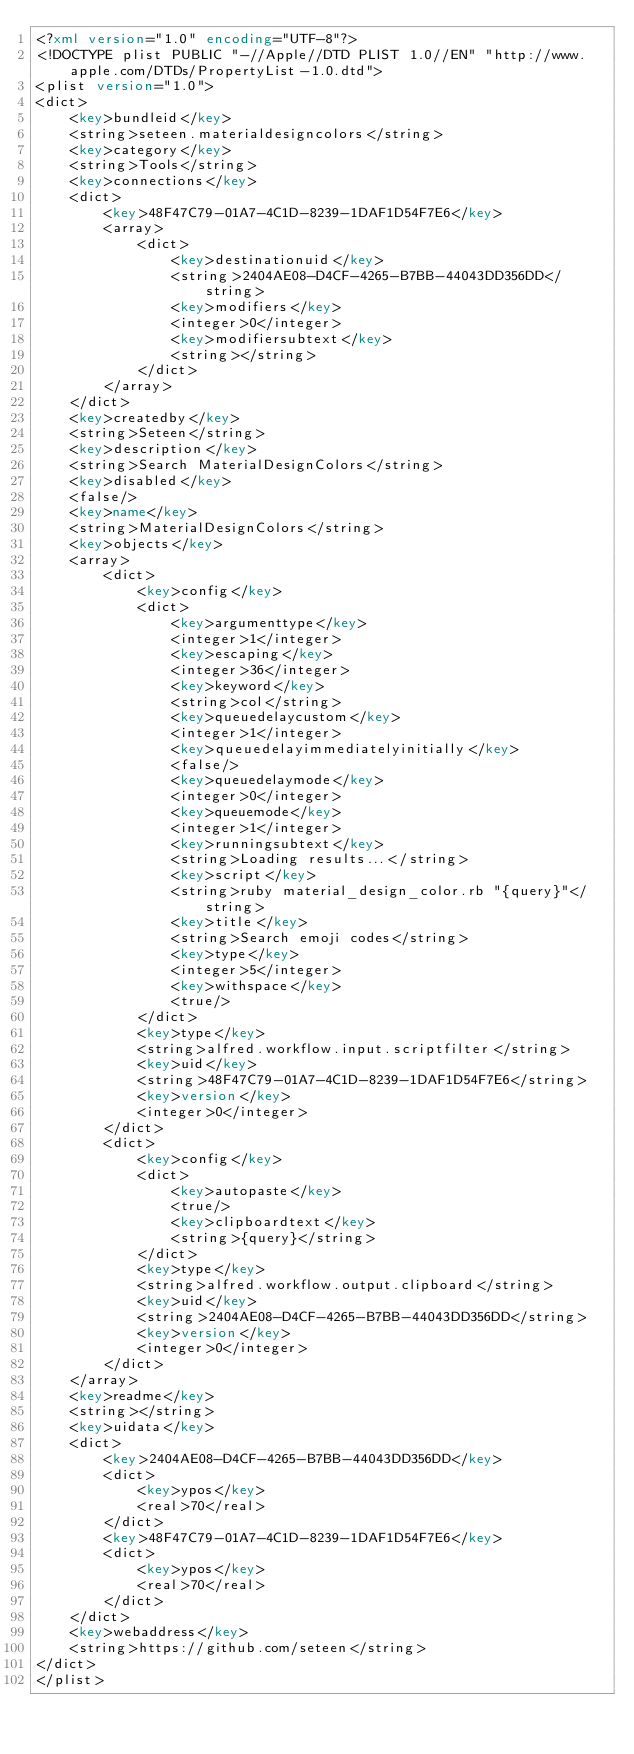Convert code to text. <code><loc_0><loc_0><loc_500><loc_500><_XML_><?xml version="1.0" encoding="UTF-8"?>
<!DOCTYPE plist PUBLIC "-//Apple//DTD PLIST 1.0//EN" "http://www.apple.com/DTDs/PropertyList-1.0.dtd">
<plist version="1.0">
<dict>
	<key>bundleid</key>
	<string>seteen.materialdesigncolors</string>
	<key>category</key>
	<string>Tools</string>
	<key>connections</key>
	<dict>
		<key>48F47C79-01A7-4C1D-8239-1DAF1D54F7E6</key>
		<array>
			<dict>
				<key>destinationuid</key>
				<string>2404AE08-D4CF-4265-B7BB-44043DD356DD</string>
				<key>modifiers</key>
				<integer>0</integer>
				<key>modifiersubtext</key>
				<string></string>
			</dict>
		</array>
	</dict>
	<key>createdby</key>
	<string>Seteen</string>
	<key>description</key>
	<string>Search MaterialDesignColors</string>
	<key>disabled</key>
	<false/>
	<key>name</key>
	<string>MaterialDesignColors</string>
	<key>objects</key>
	<array>
		<dict>
			<key>config</key>
			<dict>
				<key>argumenttype</key>
				<integer>1</integer>
				<key>escaping</key>
				<integer>36</integer>
				<key>keyword</key>
				<string>col</string>
				<key>queuedelaycustom</key>
				<integer>1</integer>
				<key>queuedelayimmediatelyinitially</key>
				<false/>
				<key>queuedelaymode</key>
				<integer>0</integer>
				<key>queuemode</key>
				<integer>1</integer>
				<key>runningsubtext</key>
				<string>Loading results...</string>
				<key>script</key>
				<string>ruby material_design_color.rb "{query}"</string>
				<key>title</key>
				<string>Search emoji codes</string>
				<key>type</key>
				<integer>5</integer>
				<key>withspace</key>
				<true/>
			</dict>
			<key>type</key>
			<string>alfred.workflow.input.scriptfilter</string>
			<key>uid</key>
			<string>48F47C79-01A7-4C1D-8239-1DAF1D54F7E6</string>
			<key>version</key>
			<integer>0</integer>
		</dict>
		<dict>
			<key>config</key>
			<dict>
				<key>autopaste</key>
				<true/>
				<key>clipboardtext</key>
				<string>{query}</string>
			</dict>
			<key>type</key>
			<string>alfred.workflow.output.clipboard</string>
			<key>uid</key>
			<string>2404AE08-D4CF-4265-B7BB-44043DD356DD</string>
			<key>version</key>
			<integer>0</integer>
		</dict>
	</array>
	<key>readme</key>
	<string></string>
	<key>uidata</key>
	<dict>
		<key>2404AE08-D4CF-4265-B7BB-44043DD356DD</key>
		<dict>
			<key>ypos</key>
			<real>70</real>
		</dict>
		<key>48F47C79-01A7-4C1D-8239-1DAF1D54F7E6</key>
		<dict>
			<key>ypos</key>
			<real>70</real>
		</dict>
	</dict>
	<key>webaddress</key>
	<string>https://github.com/seteen</string>
</dict>
</plist>
</code> 